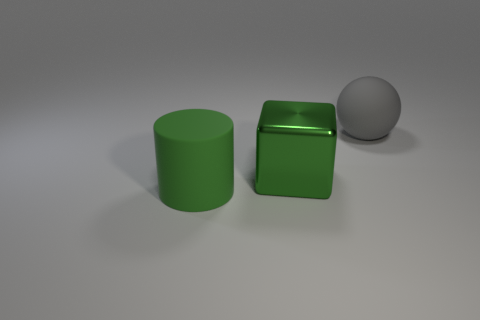How many things are either large green rubber objects or objects in front of the gray sphere?
Ensure brevity in your answer.  2. Are there any green cubes that have the same material as the big cylinder?
Your response must be concise. No. There is a block that is the same size as the gray matte thing; what is it made of?
Offer a very short reply. Metal. What material is the gray ball that is behind the rubber thing in front of the big block made of?
Give a very brief answer. Rubber. There is a big rubber object on the left side of the gray sphere; is its shape the same as the large gray object?
Provide a short and direct response. No. What color is the big thing that is the same material as the gray sphere?
Your answer should be compact. Green. There is a big green object that is behind the rubber cylinder; what material is it?
Offer a terse response. Metal. There is a big gray thing; does it have the same shape as the large thing that is in front of the green shiny thing?
Make the answer very short. No. What is the color of the rubber object that is the same size as the green matte cylinder?
Provide a succinct answer. Gray. Do the big ball and the green object on the right side of the big cylinder have the same material?
Ensure brevity in your answer.  No. 